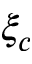Convert formula to latex. <formula><loc_0><loc_0><loc_500><loc_500>\xi _ { c }</formula> 